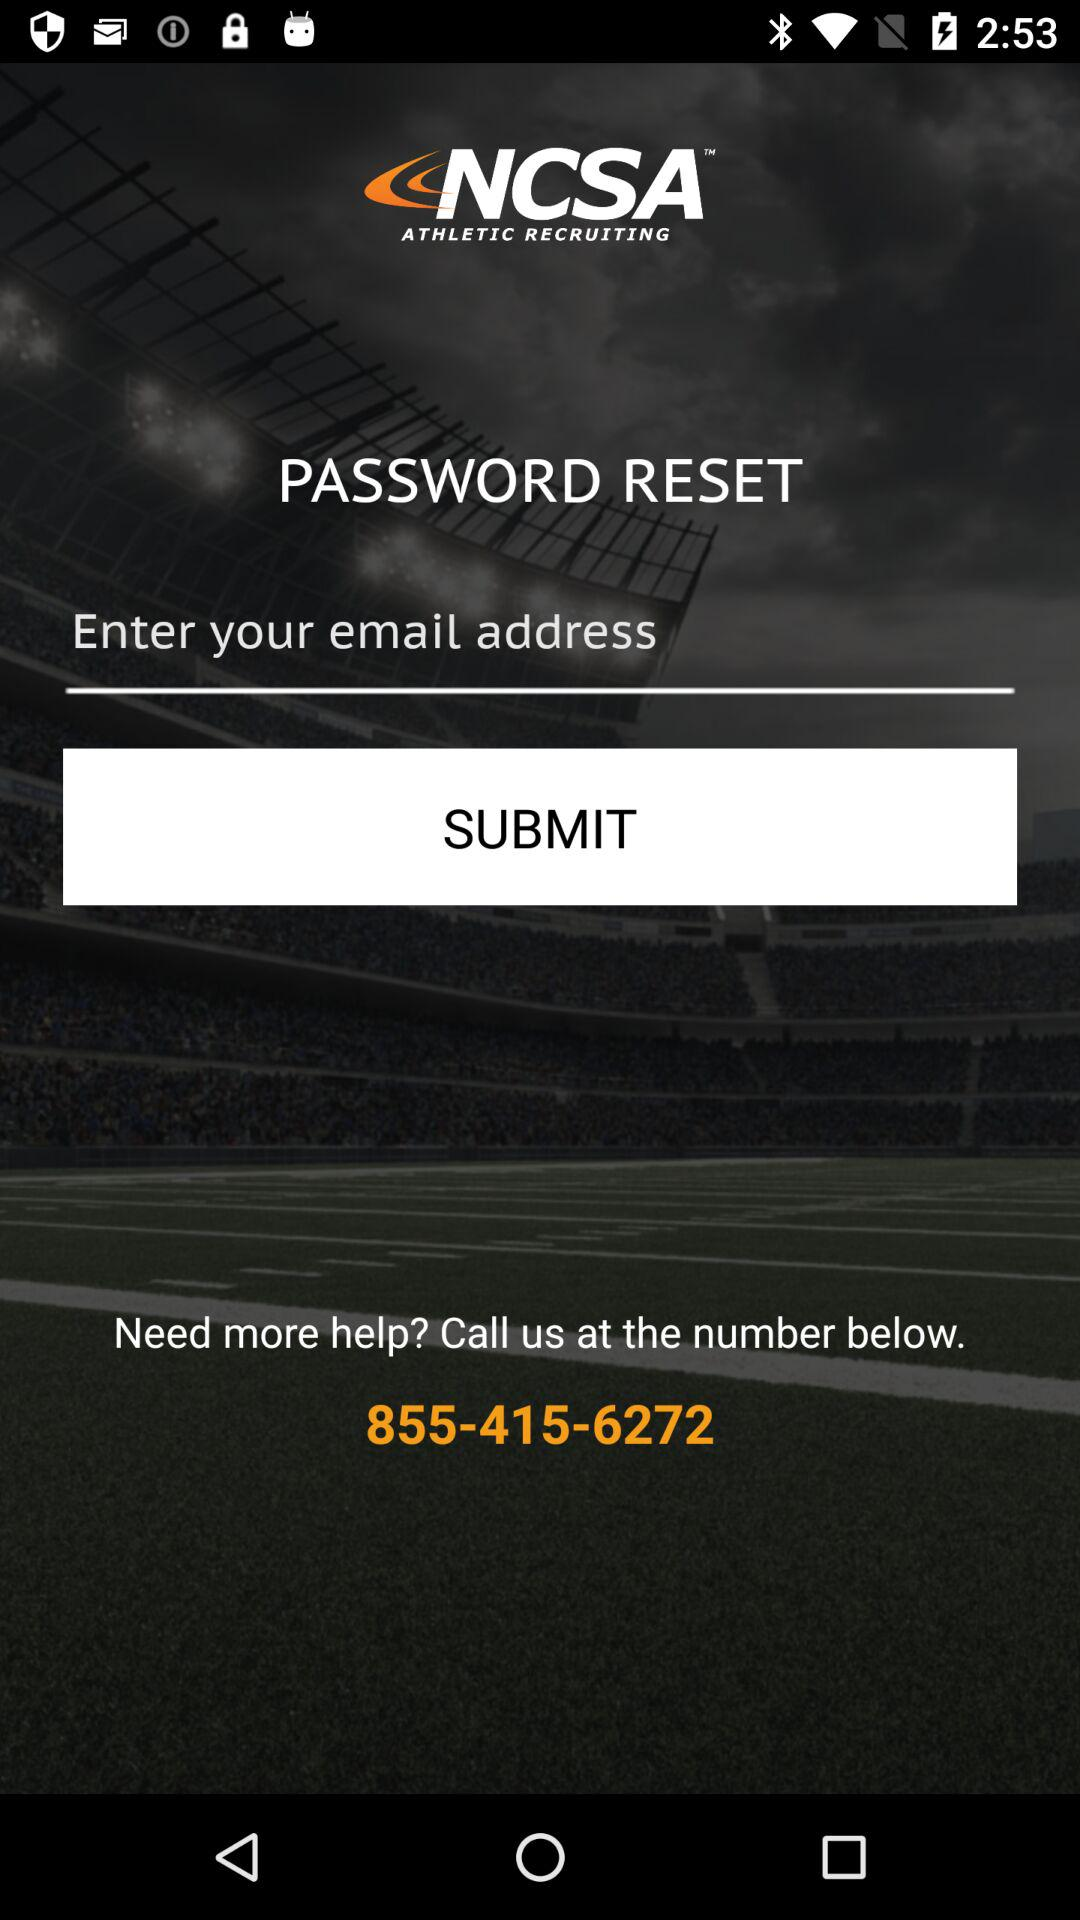What is the helpline number? The helpline number is 855-415-6272. 